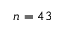<formula> <loc_0><loc_0><loc_500><loc_500>n = 4 3</formula> 